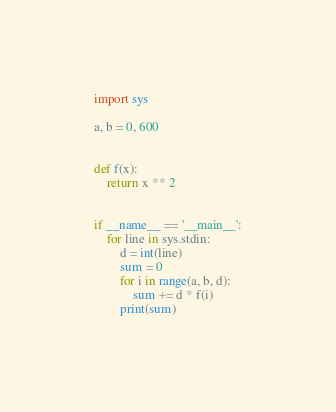<code> <loc_0><loc_0><loc_500><loc_500><_Python_>import sys

a, b = 0, 600


def f(x):
    return x ** 2


if __name__ == '__main__':
    for line in sys.stdin:
        d = int(line)
        sum = 0
        for i in range(a, b, d):
            sum += d * f(i)
        print(sum)
</code> 